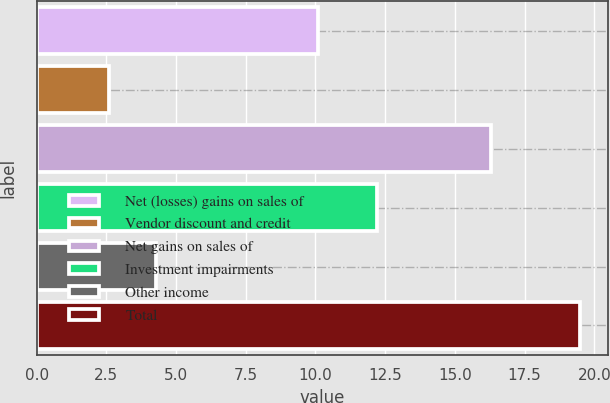<chart> <loc_0><loc_0><loc_500><loc_500><bar_chart><fcel>Net (losses) gains on sales of<fcel>Vendor discount and credit<fcel>Net gains on sales of<fcel>Investment impairments<fcel>Other income<fcel>Total<nl><fcel>10.1<fcel>2.6<fcel>16.3<fcel>12.2<fcel>4.29<fcel>19.5<nl></chart> 